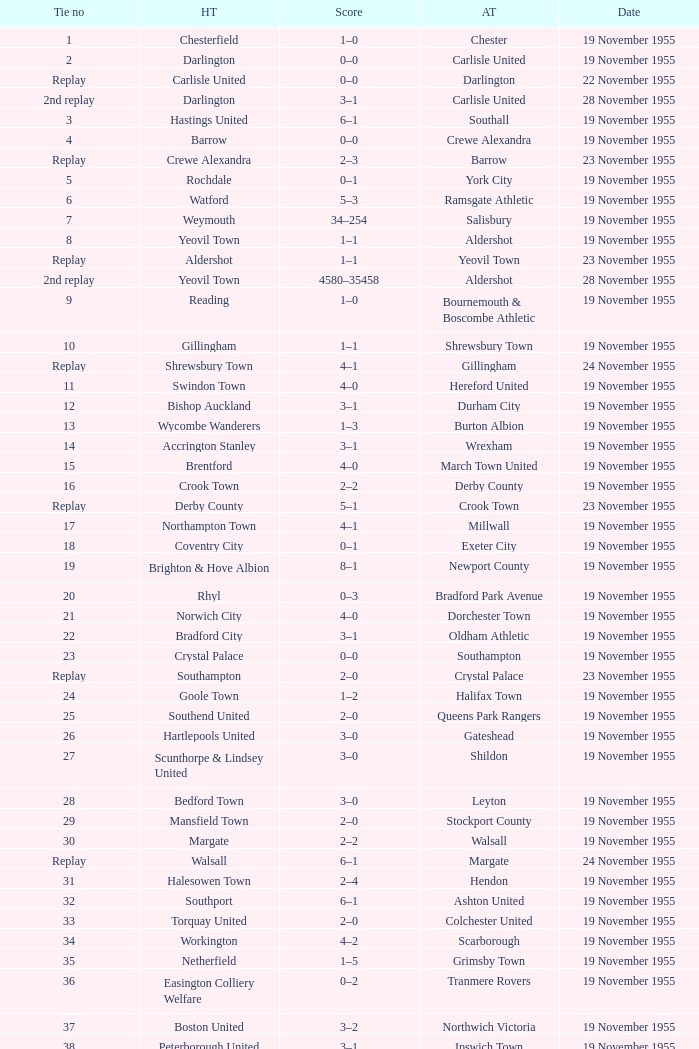What is the home team with scarborough as the away team? Workington. 